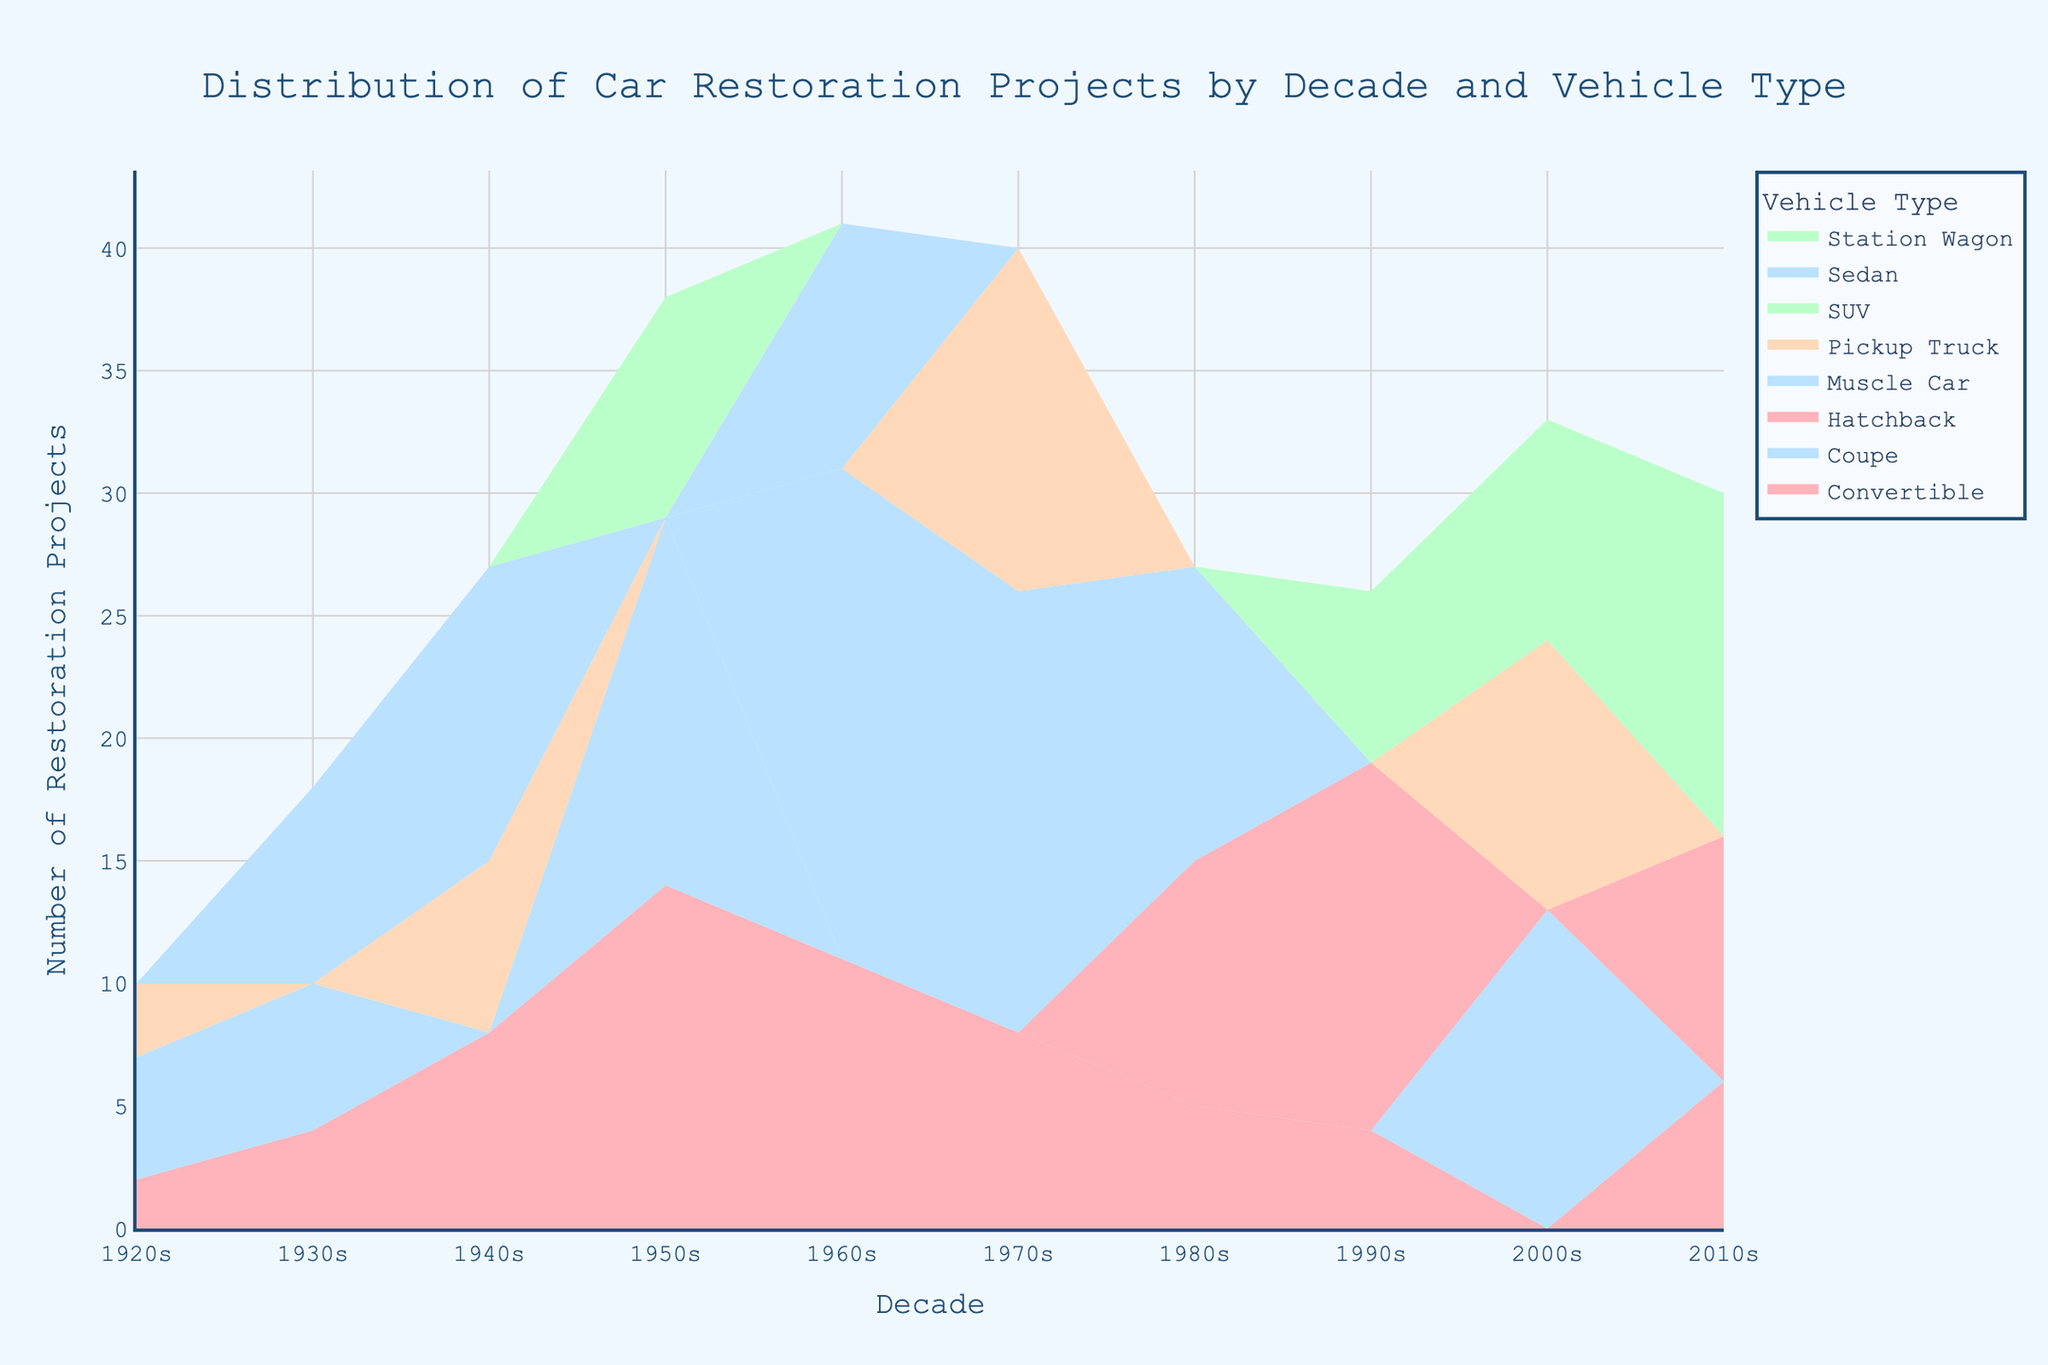What is the title of the figure? The title is prominently displayed at the top of the figure, written in a large, bold font. It reads "Distribution of Car Restoration Projects by Decade and Vehicle Type".
Answer: "Distribution of Car Restoration Projects by Decade and Vehicle Type" What are the vehicle types included in the 1940s? To identify the vehicle types from the 1940s, look at the stream sections within that decade. The types are Sedan, Pickup Truck, and Convertible.
Answer: Sedan, Pickup Truck, Convertible During which decade were Muscle Cars restored the most? Observe the stream section labeled "Muscle Car." The highest peak appears in the 1960s, indicating this is when the most restorations for Muscle Cars occurred.
Answer: 1960s How many restoration projects were there for Coupes in the 1920s? Locate the stream section related to Coupes in the 1920s. The streamgraph showing the Coupe data reveals 5 restoration projects.
Answer: 5 Compare the restoration projects of Pickup Trucks in the 2000s and the 1970s. Which decade had more projects? Identify the stream sections for Pickup Trucks in both decades. The 2000s show 11 projects, whereas the 1970s show 14 projects, so the 1970s had more restoration projects.
Answer: 1970s Which vehicle type had the least number of restoration projects in the 1990s? Check the stream sections within the 1990s and identify the vehicle type with the smallest height. The Convertible has 4 restoration projects, which is the least in that decade.
Answer: Convertible What is the total number of restoration projects for SUVs across all decades? Sum up the values of the stream sections labeled SUV. These are 7 (1990s) + 9 (2000s) + 14 (2010s) = 30 projects.
Answer: 30 Which vehicle type shows a consistent increase in restoration projects from the 1990s to the 2010s? Analyze the trends in the SUV stream section. The number increases from 7 in the 1990s to 9 in the 2000s and then to 14 in the 2010s, indicating a consistent rise.
Answer: SUV How did the number of Convertible restoration projects change from the 1950s to the 1960s? Observe the Convertible stream in the 1950s and 1960s. It increases from 14 projects in the 1950s to 11 in the 1960s, signifying a decrease.
Answer: Decrease Which decade saw the highest diversity (most types) of vehicle restoration projects? Locate the decade with the most distinct stream sections. The 2010s show SUV, Hatchback, and Convertible stream sections, making it diversified.
Answer: 2010s 